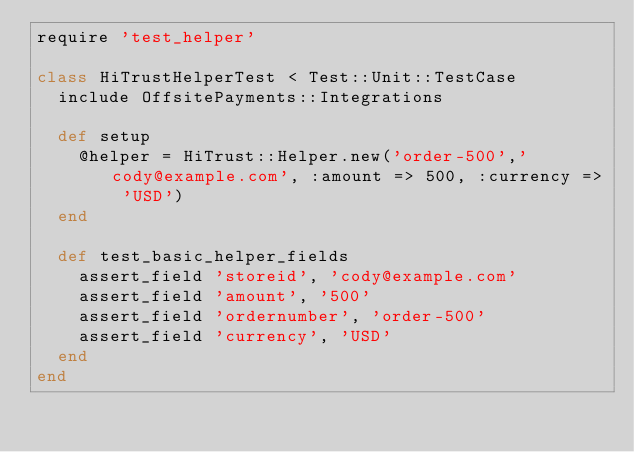Convert code to text. <code><loc_0><loc_0><loc_500><loc_500><_Ruby_>require 'test_helper'

class HiTrustHelperTest < Test::Unit::TestCase
  include OffsitePayments::Integrations

  def setup
    @helper = HiTrust::Helper.new('order-500','cody@example.com', :amount => 500, :currency => 'USD')
  end

  def test_basic_helper_fields
    assert_field 'storeid', 'cody@example.com'
    assert_field 'amount', '500'
    assert_field 'ordernumber', 'order-500'
    assert_field 'currency', 'USD'
  end
end
</code> 